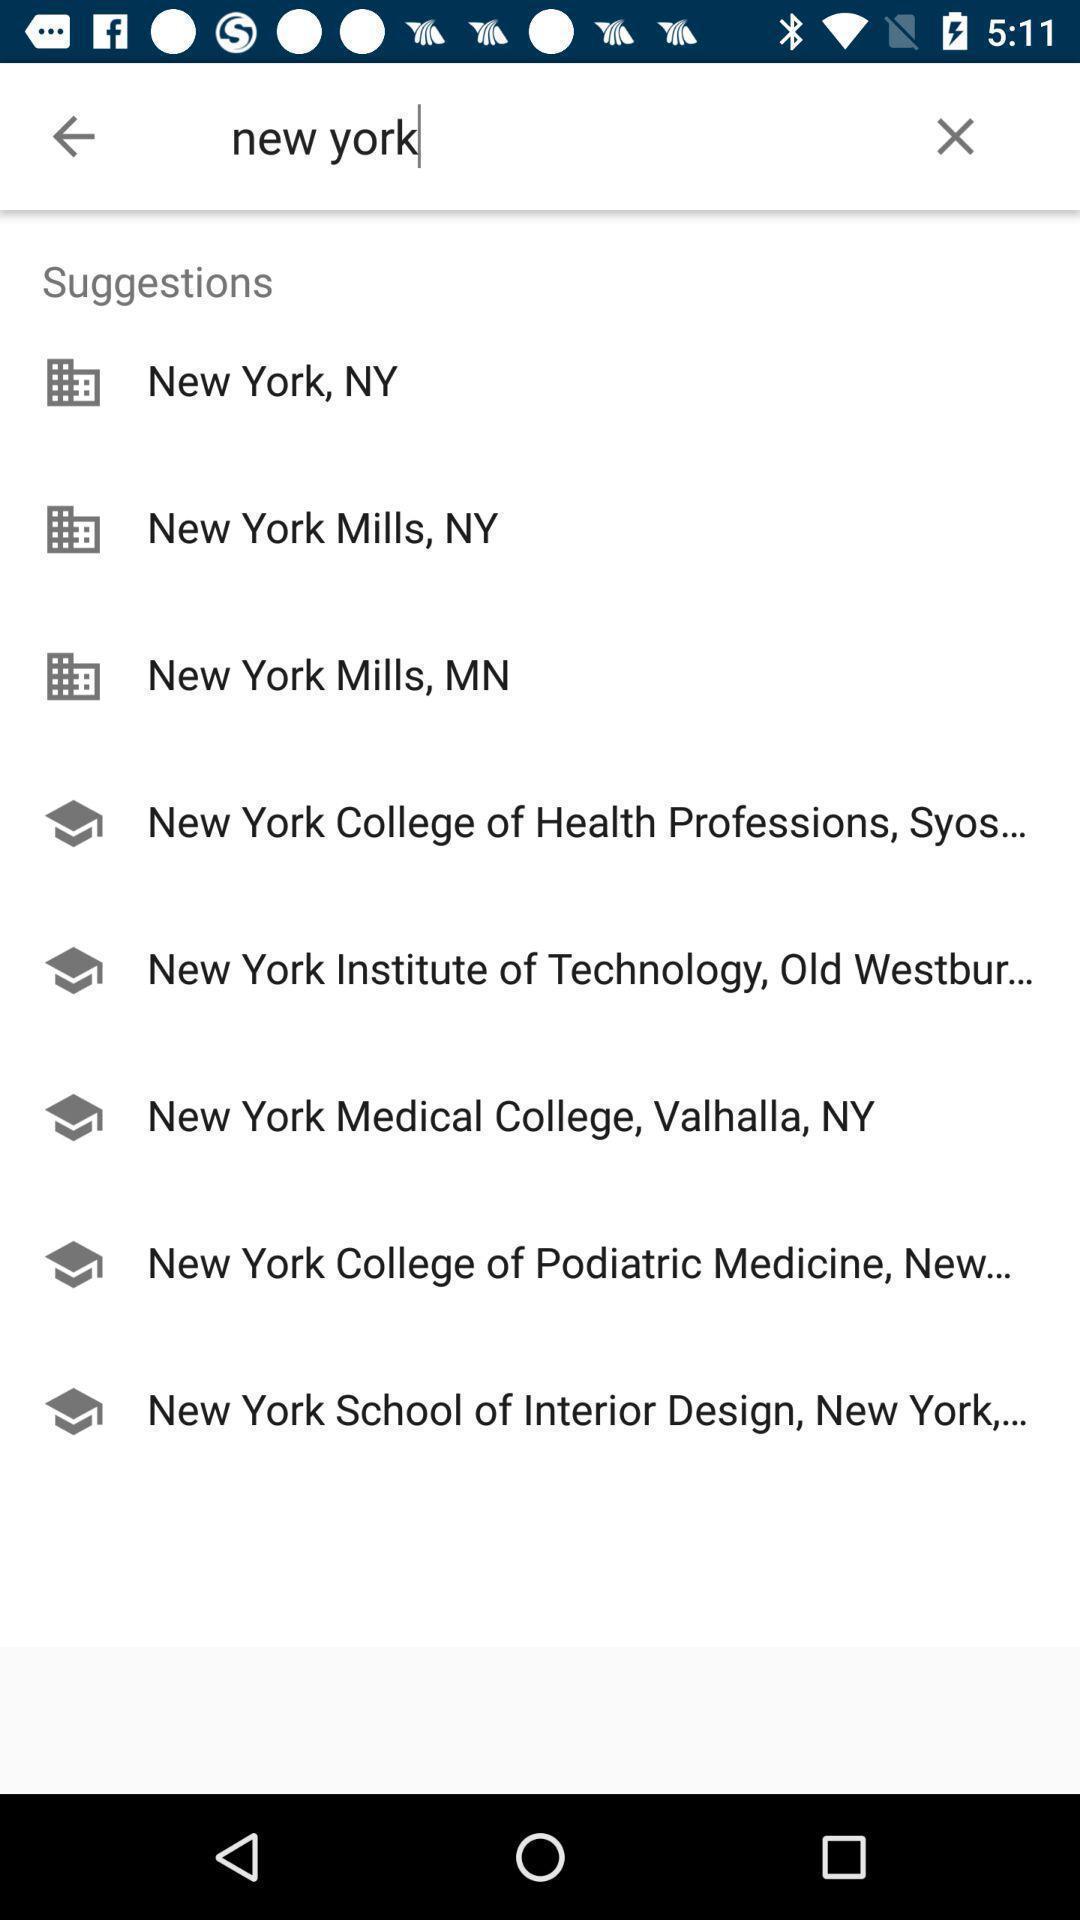Give me a narrative description of this picture. Screen displaying multiple location suggestion names. 